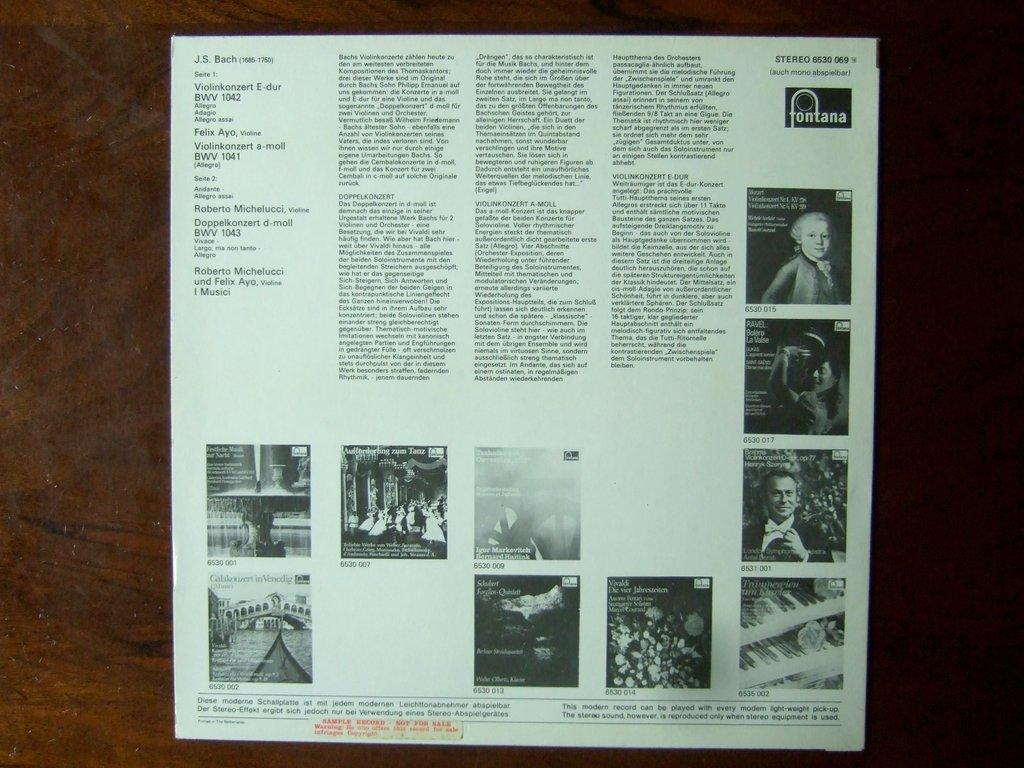What is featured on the poster in the image? The poster in the image has both text and images on it. Can you describe the surface that the poster is placed on? The wooden surface in the image is likely a table. How does the expert use the wire and umbrella in the image? There is no expert, wire, or umbrella present in the image. 